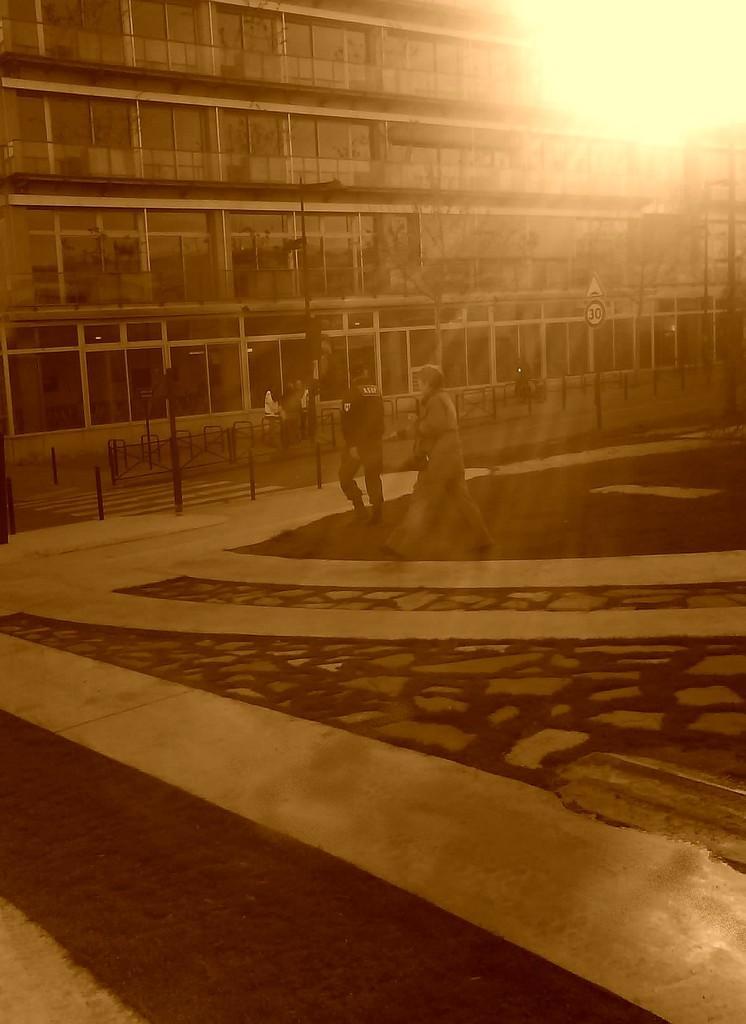Please provide a concise description of this image. In the foreground of this image, there is grass and paths on which there are two people walking. In the background, there are few bollards, railing, poles, a building and the sun at the top. 